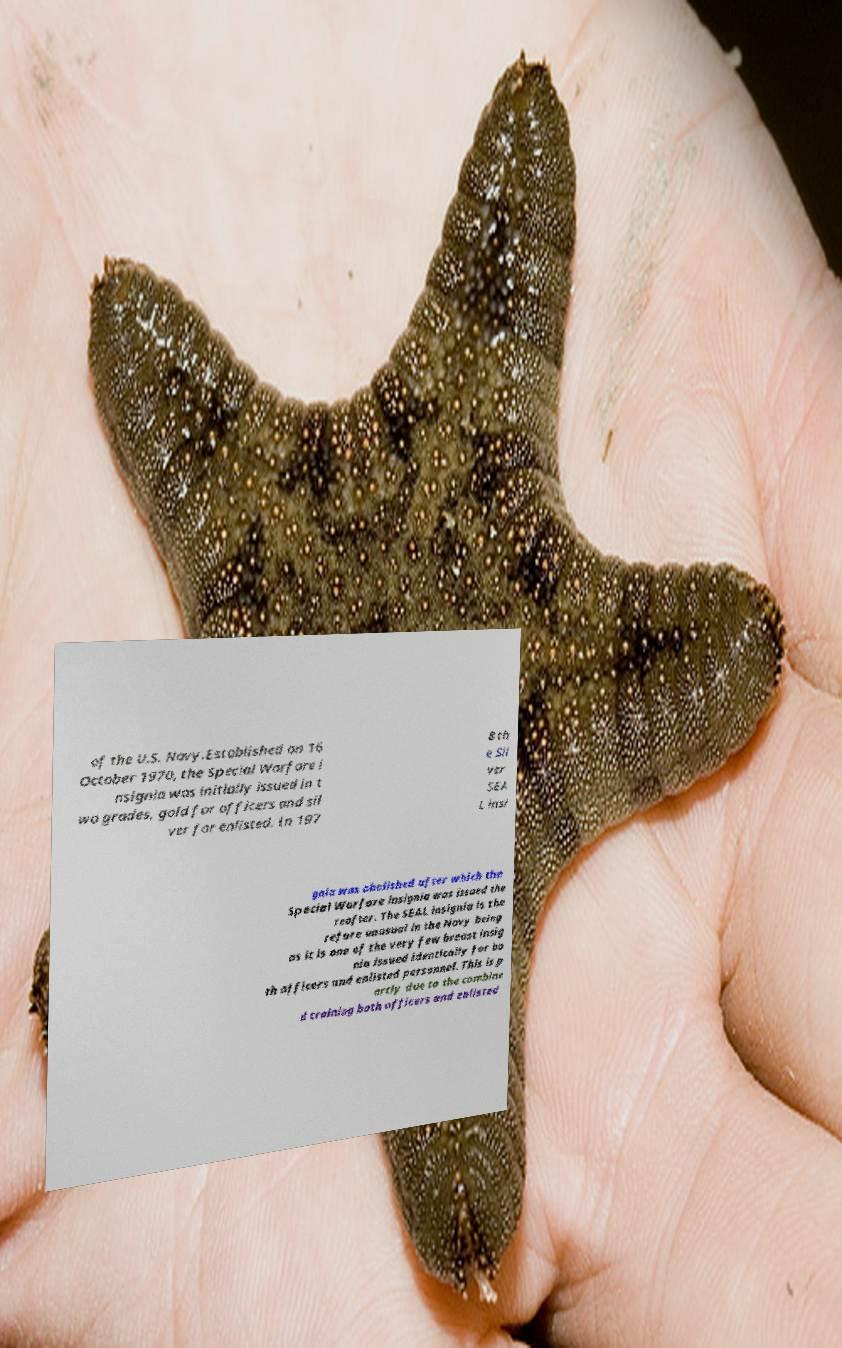What messages or text are displayed in this image? I need them in a readable, typed format. of the U.S. Navy.Established on 16 October 1970, the Special Warfare i nsignia was initially issued in t wo grades, gold for officers and sil ver for enlisted. In 197 8 th e Sil ver SEA L insi gnia was abolished after which the Special Warfare insignia was issued the reafter. The SEAL insignia is the refore unusual in the Navy being as it is one of the very few breast insig nia issued identically for bo th officers and enlisted personnel. This is p artly due to the combine d training both officers and enlisted 